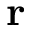<formula> <loc_0><loc_0><loc_500><loc_500>r</formula> 